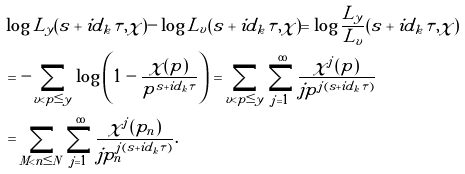Convert formula to latex. <formula><loc_0><loc_0><loc_500><loc_500>& \log L _ { y } ( s + i d _ { k } \tau , \chi ) - \log L _ { v } ( s + i d _ { k } \tau , \chi ) = \log \frac { L _ { y } } { L _ { v } } ( s + i d _ { k } \tau , \chi ) \\ & = - \sum _ { v < p \leq y } \log \left ( 1 - \frac { \chi ( p ) } { p ^ { s + i d _ { k } \tau } } \right ) = \sum _ { v < p \leq y } \sum _ { j = 1 } ^ { \infty } \frac { \chi ^ { j } ( p ) } { j p ^ { j ( s + i d _ { k } \tau ) } } \\ & = \sum _ { M < n \leq N } \sum _ { j = 1 } ^ { \infty } \frac { \chi ^ { j } ( p _ { n } ) } { j p _ { n } ^ { j ( s + i d _ { k } \tau ) } } .</formula> 